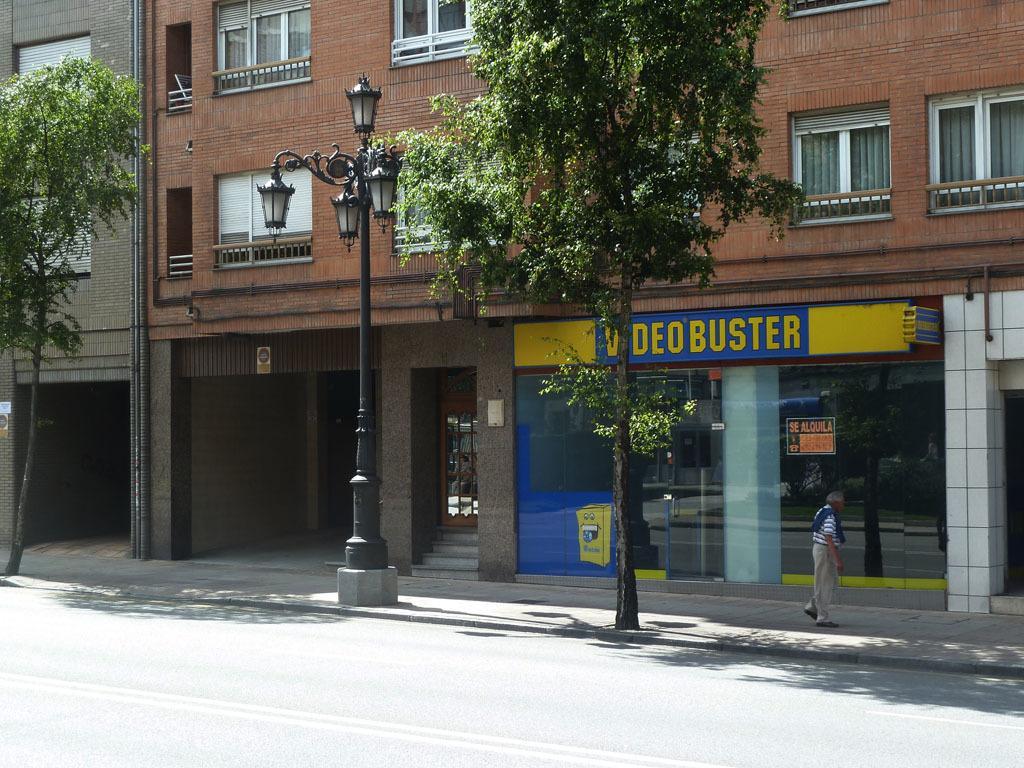In one or two sentences, can you explain what this image depicts? In this image, there are a few buildings. We can see some stairs and a pole with some lights. There are a few trees. We can see a person. We can see some boards with text. We can also some glass. We can see the reflection of trees and the ground on the glass. 